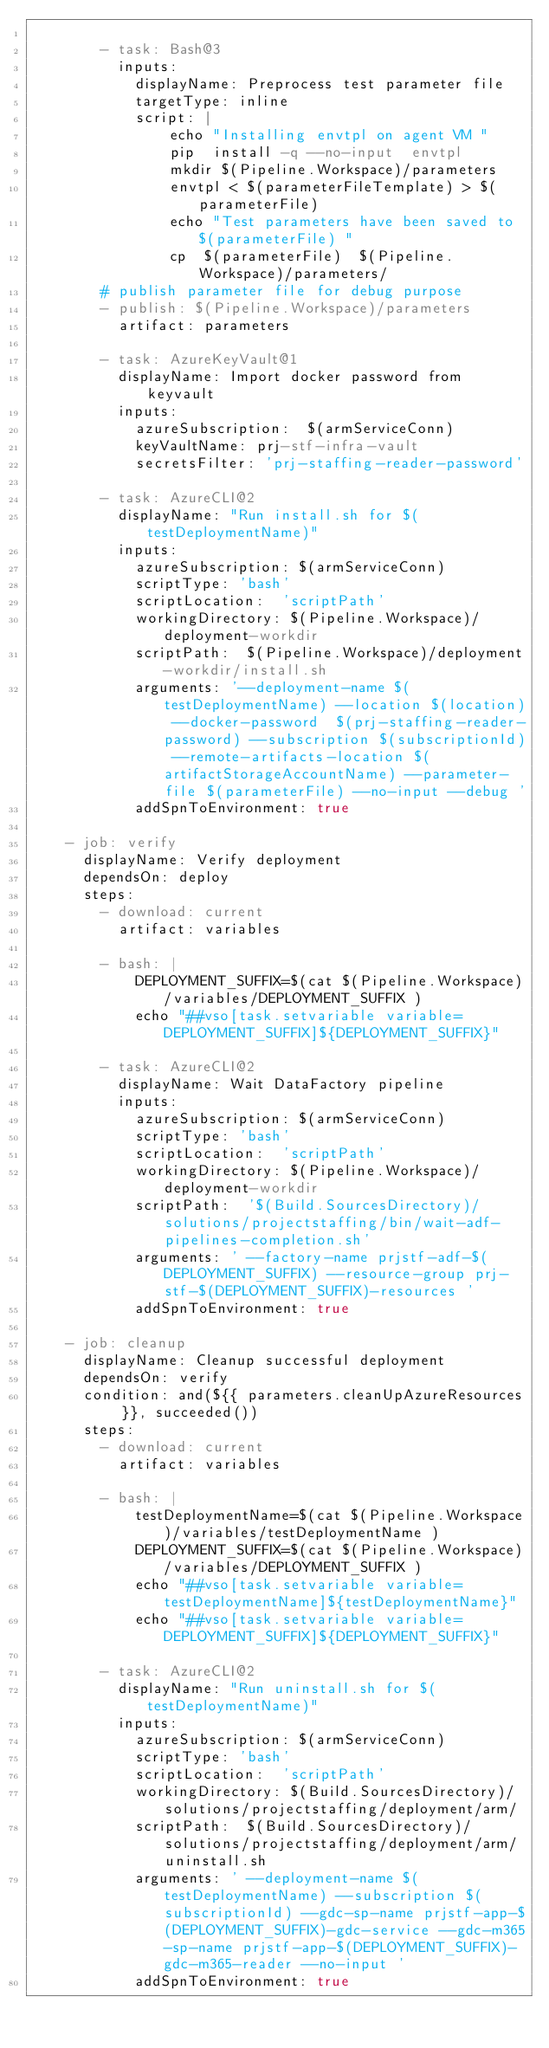<code> <loc_0><loc_0><loc_500><loc_500><_YAML_>
        - task: Bash@3
          inputs:
            displayName: Preprocess test parameter file
            targetType: inline
            script: |
                echo "Installing envtpl on agent VM "
                pip  install -q --no-input  envtpl
                mkdir $(Pipeline.Workspace)/parameters
                envtpl < $(parameterFileTemplate) > $(parameterFile)
                echo "Test parameters have been saved to $(parameterFile) "
                cp  $(parameterFile)  $(Pipeline.Workspace)/parameters/
        # publish parameter file for debug purpose
        - publish: $(Pipeline.Workspace)/parameters
          artifact: parameters

        - task: AzureKeyVault@1
          displayName: Import docker password from keyvault
          inputs:
            azureSubscription:  $(armServiceConn)
            keyVaultName: prj-stf-infra-vault
            secretsFilter: 'prj-staffing-reader-password'

        - task: AzureCLI@2
          displayName: "Run install.sh for $(testDeploymentName)"
          inputs:
            azureSubscription: $(armServiceConn)
            scriptType: 'bash'
            scriptLocation:  'scriptPath'
            workingDirectory: $(Pipeline.Workspace)/deployment-workdir
            scriptPath:  $(Pipeline.Workspace)/deployment-workdir/install.sh
            arguments: '--deployment-name $(testDeploymentName) --location $(location) --docker-password  $(prj-staffing-reader-password) --subscription $(subscriptionId) --remote-artifacts-location $(artifactStorageAccountName) --parameter-file $(parameterFile) --no-input --debug '
            addSpnToEnvironment: true

    - job: verify
      displayName: Verify deployment
      dependsOn: deploy
      steps:
        - download: current
          artifact: variables

        - bash: |
            DEPLOYMENT_SUFFIX=$(cat $(Pipeline.Workspace)/variables/DEPLOYMENT_SUFFIX )
            echo "##vso[task.setvariable variable=DEPLOYMENT_SUFFIX]${DEPLOYMENT_SUFFIX}"

        - task: AzureCLI@2
          displayName: Wait DataFactory pipeline
          inputs:
            azureSubscription: $(armServiceConn)
            scriptType: 'bash'
            scriptLocation:  'scriptPath'
            workingDirectory: $(Pipeline.Workspace)/deployment-workdir
            scriptPath:  '$(Build.SourcesDirectory)/solutions/projectstaffing/bin/wait-adf-pipelines-completion.sh'
            arguments: ' --factory-name prjstf-adf-$(DEPLOYMENT_SUFFIX) --resource-group prj-stf-$(DEPLOYMENT_SUFFIX)-resources '
            addSpnToEnvironment: true

    - job: cleanup
      displayName: Cleanup successful deployment
      dependsOn: verify
      condition: and(${{ parameters.cleanUpAzureResources }}, succeeded())
      steps:
        - download: current
          artifact: variables

        - bash: |
            testDeploymentName=$(cat $(Pipeline.Workspace)/variables/testDeploymentName )
            DEPLOYMENT_SUFFIX=$(cat $(Pipeline.Workspace)/variables/DEPLOYMENT_SUFFIX )
            echo "##vso[task.setvariable variable=testDeploymentName]${testDeploymentName}"
            echo "##vso[task.setvariable variable=DEPLOYMENT_SUFFIX]${DEPLOYMENT_SUFFIX}"

        - task: AzureCLI@2
          displayName: "Run uninstall.sh for $(testDeploymentName)"
          inputs:
            azureSubscription: $(armServiceConn)
            scriptType: 'bash'
            scriptLocation:  'scriptPath'
            workingDirectory: $(Build.SourcesDirectory)/solutions/projectstaffing/deployment/arm/
            scriptPath:  $(Build.SourcesDirectory)/solutions/projectstaffing/deployment/arm/uninstall.sh
            arguments: ' --deployment-name $(testDeploymentName) --subscription $(subscriptionId) --gdc-sp-name prjstf-app-$(DEPLOYMENT_SUFFIX)-gdc-service --gdc-m365-sp-name prjstf-app-$(DEPLOYMENT_SUFFIX)-gdc-m365-reader --no-input '
            addSpnToEnvironment: true
</code> 